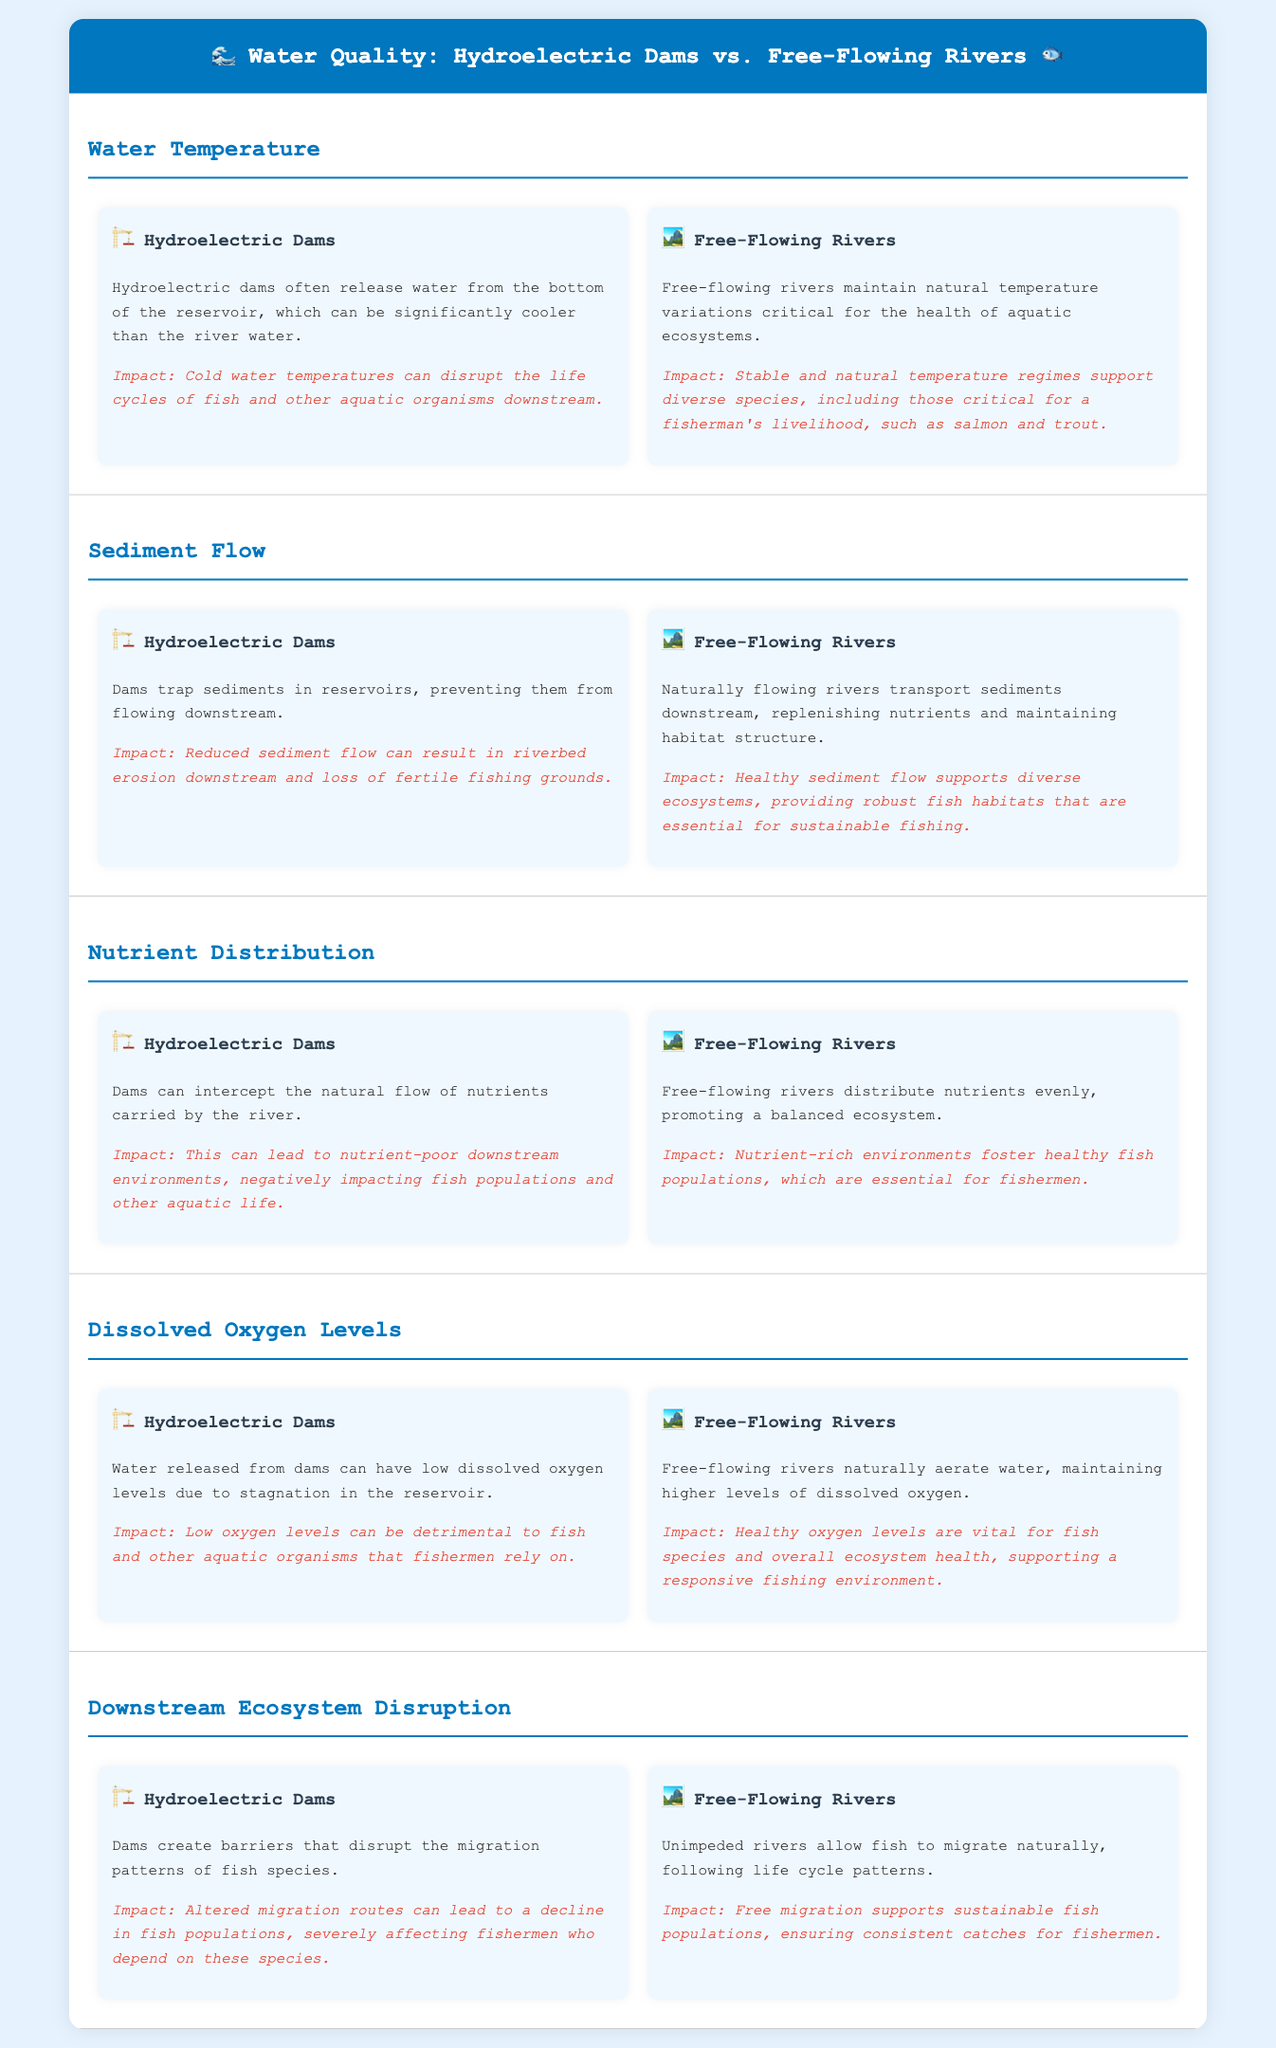What is the impact of hydroelectric dams on water temperature? Hydroelectric dams release water from the bottom of the reservoir, which can be significantly cooler than the river water, disrupting life cycles of aquatic organisms downstream.
Answer: Cold water temperatures disrupt life cycles What is one effect of sediment flow in free-flowing rivers? Free-flowing rivers transport sediments downstream, which replenishes nutrients and maintains habitat structure essential for fish.
Answer: Supports diverse ecosystems How do hydroelectric dams affect nutrient distribution? Dams can intercept the natural flow of nutrients carried by the river, leading to nutrient-poor environments downstream affecting fish populations.
Answer: Result in nutrient-poor environments What is a key difference in dissolved oxygen levels between hydroelectric dams and free-flowing rivers? Water released from dams can have low dissolved oxygen levels due to stagnation, while free-flowing rivers naturally aerate water maintaining higher levels of dissolved oxygen.
Answer: Low vs. high dissolved oxygen levels What do free-flowing rivers allow fish to do? Free-flowing rivers enable fish to migrate naturally, following their life cycle patterns without barriers.
Answer: Allow natural migration 